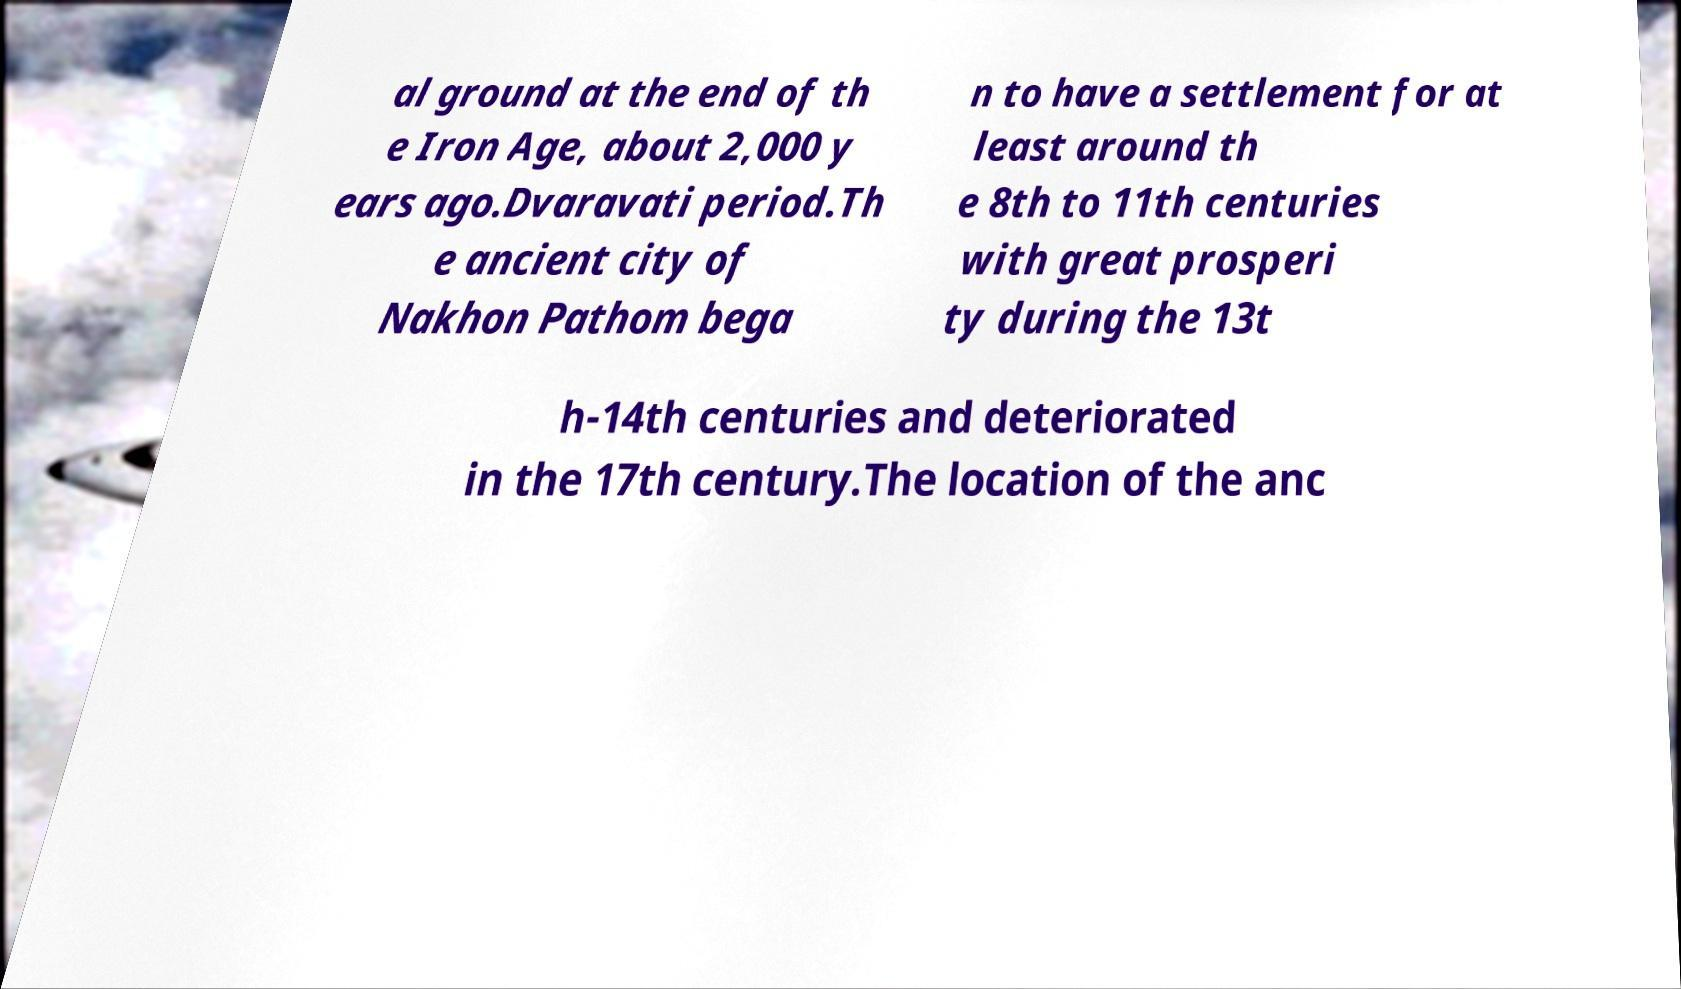What messages or text are displayed in this image? I need them in a readable, typed format. al ground at the end of th e Iron Age, about 2,000 y ears ago.Dvaravati period.Th e ancient city of Nakhon Pathom bega n to have a settlement for at least around th e 8th to 11th centuries with great prosperi ty during the 13t h-14th centuries and deteriorated in the 17th century.The location of the anc 